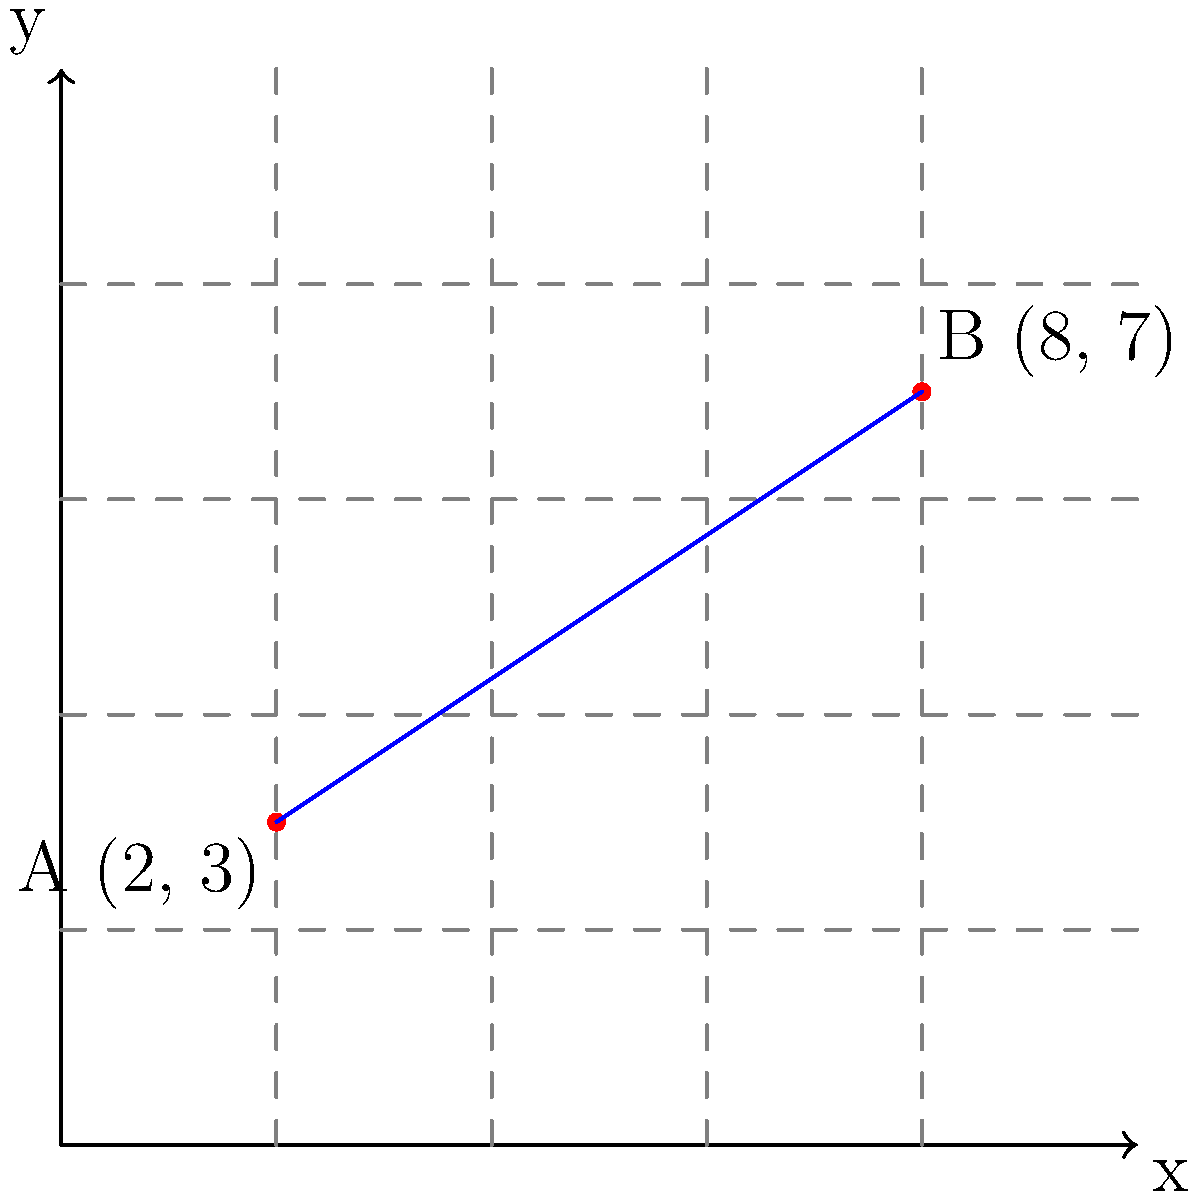In a quaint coastal village reminiscent of those in Enid Blyton's stories, two charming seaside cottages are situated on a coordinate plane. Cottage A is located at (2, 3), while Cottage B is at (8, 7). What is the straight-line distance between these two cottages? Round your answer to two decimal places. Let's solve this step-by-step using the distance formula:

1) The distance formula is derived from the Pythagorean theorem:
   $$d = \sqrt{(x_2-x_1)^2 + (y_2-y_1)^2}$$
   where $(x_1,y_1)$ is the coordinate of the first point and $(x_2,y_2)$ is the coordinate of the second point.

2) We have:
   Cottage A: $(x_1,y_1) = (2,3)$
   Cottage B: $(x_2,y_2) = (8,7)$

3) Let's substitute these into the formula:
   $$d = \sqrt{(8-2)^2 + (7-3)^2}$$

4) Simplify inside the parentheses:
   $$d = \sqrt{6^2 + 4^2}$$

5) Calculate the squares:
   $$d = \sqrt{36 + 16}$$

6) Add inside the square root:
   $$d = \sqrt{52}$$

7) Simplify the square root:
   $$d = 2\sqrt{13}$$

8) Use a calculator to evaluate and round to two decimal places:
   $$d \approx 7.21$$

Therefore, the distance between the two cottages is approximately 7.21 units.
Answer: 7.21 units 